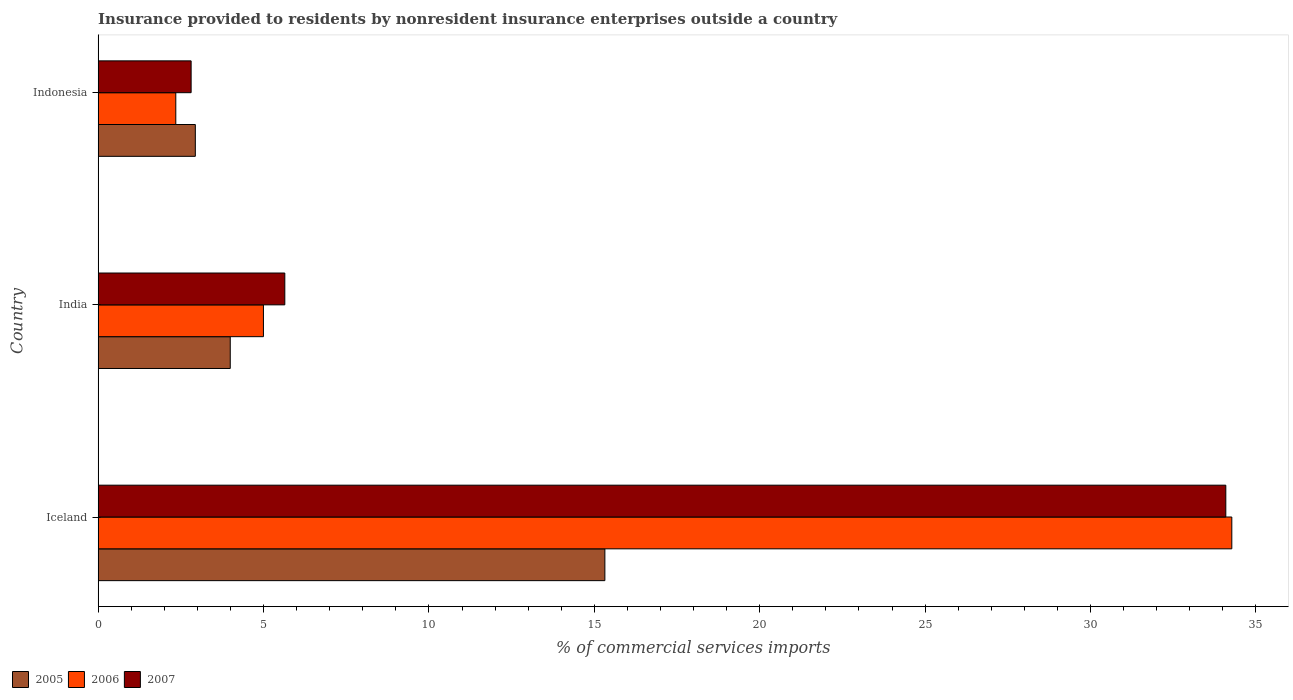How many different coloured bars are there?
Offer a terse response. 3. How many groups of bars are there?
Provide a short and direct response. 3. Are the number of bars per tick equal to the number of legend labels?
Offer a very short reply. Yes. How many bars are there on the 2nd tick from the bottom?
Your answer should be compact. 3. What is the label of the 3rd group of bars from the top?
Ensure brevity in your answer.  Iceland. What is the Insurance provided to residents in 2005 in Iceland?
Ensure brevity in your answer.  15.32. Across all countries, what is the maximum Insurance provided to residents in 2005?
Your answer should be very brief. 15.32. Across all countries, what is the minimum Insurance provided to residents in 2006?
Your answer should be very brief. 2.35. In which country was the Insurance provided to residents in 2007 maximum?
Offer a very short reply. Iceland. What is the total Insurance provided to residents in 2006 in the graph?
Ensure brevity in your answer.  41.62. What is the difference between the Insurance provided to residents in 2005 in Iceland and that in India?
Offer a terse response. 11.32. What is the difference between the Insurance provided to residents in 2007 in India and the Insurance provided to residents in 2006 in Iceland?
Offer a very short reply. -28.63. What is the average Insurance provided to residents in 2005 per country?
Your answer should be very brief. 7.42. What is the difference between the Insurance provided to residents in 2005 and Insurance provided to residents in 2007 in India?
Keep it short and to the point. -1.65. In how many countries, is the Insurance provided to residents in 2007 greater than 2 %?
Give a very brief answer. 3. What is the ratio of the Insurance provided to residents in 2006 in Iceland to that in India?
Your answer should be very brief. 6.86. What is the difference between the highest and the second highest Insurance provided to residents in 2007?
Keep it short and to the point. 28.45. What is the difference between the highest and the lowest Insurance provided to residents in 2007?
Offer a very short reply. 31.28. In how many countries, is the Insurance provided to residents in 2006 greater than the average Insurance provided to residents in 2006 taken over all countries?
Give a very brief answer. 1. What does the 3rd bar from the bottom in Iceland represents?
Give a very brief answer. 2007. Are all the bars in the graph horizontal?
Make the answer very short. Yes. How many countries are there in the graph?
Your answer should be compact. 3. Are the values on the major ticks of X-axis written in scientific E-notation?
Offer a terse response. No. Does the graph contain any zero values?
Offer a terse response. No. Does the graph contain grids?
Your answer should be compact. No. How are the legend labels stacked?
Offer a terse response. Horizontal. What is the title of the graph?
Your response must be concise. Insurance provided to residents by nonresident insurance enterprises outside a country. What is the label or title of the X-axis?
Your response must be concise. % of commercial services imports. What is the label or title of the Y-axis?
Ensure brevity in your answer.  Country. What is the % of commercial services imports in 2005 in Iceland?
Your answer should be very brief. 15.32. What is the % of commercial services imports in 2006 in Iceland?
Offer a very short reply. 34.27. What is the % of commercial services imports of 2007 in Iceland?
Offer a terse response. 34.09. What is the % of commercial services imports of 2005 in India?
Your response must be concise. 3.99. What is the % of commercial services imports of 2006 in India?
Your answer should be very brief. 5. What is the % of commercial services imports of 2007 in India?
Provide a succinct answer. 5.64. What is the % of commercial services imports in 2005 in Indonesia?
Your answer should be very brief. 2.94. What is the % of commercial services imports in 2006 in Indonesia?
Your response must be concise. 2.35. What is the % of commercial services imports in 2007 in Indonesia?
Your answer should be compact. 2.81. Across all countries, what is the maximum % of commercial services imports in 2005?
Ensure brevity in your answer.  15.32. Across all countries, what is the maximum % of commercial services imports in 2006?
Provide a short and direct response. 34.27. Across all countries, what is the maximum % of commercial services imports in 2007?
Your answer should be compact. 34.09. Across all countries, what is the minimum % of commercial services imports in 2005?
Ensure brevity in your answer.  2.94. Across all countries, what is the minimum % of commercial services imports of 2006?
Make the answer very short. 2.35. Across all countries, what is the minimum % of commercial services imports of 2007?
Provide a short and direct response. 2.81. What is the total % of commercial services imports of 2005 in the graph?
Provide a short and direct response. 22.25. What is the total % of commercial services imports of 2006 in the graph?
Ensure brevity in your answer.  41.62. What is the total % of commercial services imports in 2007 in the graph?
Your answer should be compact. 42.54. What is the difference between the % of commercial services imports of 2005 in Iceland and that in India?
Give a very brief answer. 11.32. What is the difference between the % of commercial services imports of 2006 in Iceland and that in India?
Offer a very short reply. 29.27. What is the difference between the % of commercial services imports of 2007 in Iceland and that in India?
Your answer should be compact. 28.45. What is the difference between the % of commercial services imports of 2005 in Iceland and that in Indonesia?
Your answer should be compact. 12.38. What is the difference between the % of commercial services imports of 2006 in Iceland and that in Indonesia?
Provide a succinct answer. 31.92. What is the difference between the % of commercial services imports of 2007 in Iceland and that in Indonesia?
Offer a very short reply. 31.28. What is the difference between the % of commercial services imports of 2005 in India and that in Indonesia?
Give a very brief answer. 1.06. What is the difference between the % of commercial services imports in 2006 in India and that in Indonesia?
Provide a succinct answer. 2.65. What is the difference between the % of commercial services imports of 2007 in India and that in Indonesia?
Offer a very short reply. 2.83. What is the difference between the % of commercial services imports in 2005 in Iceland and the % of commercial services imports in 2006 in India?
Your answer should be compact. 10.32. What is the difference between the % of commercial services imports in 2005 in Iceland and the % of commercial services imports in 2007 in India?
Provide a short and direct response. 9.68. What is the difference between the % of commercial services imports of 2006 in Iceland and the % of commercial services imports of 2007 in India?
Your answer should be very brief. 28.63. What is the difference between the % of commercial services imports of 2005 in Iceland and the % of commercial services imports of 2006 in Indonesia?
Ensure brevity in your answer.  12.97. What is the difference between the % of commercial services imports of 2005 in Iceland and the % of commercial services imports of 2007 in Indonesia?
Give a very brief answer. 12.51. What is the difference between the % of commercial services imports of 2006 in Iceland and the % of commercial services imports of 2007 in Indonesia?
Provide a short and direct response. 31.46. What is the difference between the % of commercial services imports in 2005 in India and the % of commercial services imports in 2006 in Indonesia?
Make the answer very short. 1.65. What is the difference between the % of commercial services imports in 2005 in India and the % of commercial services imports in 2007 in Indonesia?
Provide a short and direct response. 1.18. What is the difference between the % of commercial services imports in 2006 in India and the % of commercial services imports in 2007 in Indonesia?
Keep it short and to the point. 2.19. What is the average % of commercial services imports of 2005 per country?
Offer a terse response. 7.42. What is the average % of commercial services imports of 2006 per country?
Make the answer very short. 13.87. What is the average % of commercial services imports in 2007 per country?
Make the answer very short. 14.18. What is the difference between the % of commercial services imports of 2005 and % of commercial services imports of 2006 in Iceland?
Offer a very short reply. -18.95. What is the difference between the % of commercial services imports in 2005 and % of commercial services imports in 2007 in Iceland?
Keep it short and to the point. -18.77. What is the difference between the % of commercial services imports in 2006 and % of commercial services imports in 2007 in Iceland?
Your response must be concise. 0.18. What is the difference between the % of commercial services imports of 2005 and % of commercial services imports of 2006 in India?
Your response must be concise. -1. What is the difference between the % of commercial services imports in 2005 and % of commercial services imports in 2007 in India?
Provide a succinct answer. -1.65. What is the difference between the % of commercial services imports in 2006 and % of commercial services imports in 2007 in India?
Your response must be concise. -0.65. What is the difference between the % of commercial services imports in 2005 and % of commercial services imports in 2006 in Indonesia?
Provide a succinct answer. 0.59. What is the difference between the % of commercial services imports in 2005 and % of commercial services imports in 2007 in Indonesia?
Your answer should be very brief. 0.13. What is the difference between the % of commercial services imports of 2006 and % of commercial services imports of 2007 in Indonesia?
Provide a short and direct response. -0.46. What is the ratio of the % of commercial services imports in 2005 in Iceland to that in India?
Keep it short and to the point. 3.84. What is the ratio of the % of commercial services imports of 2006 in Iceland to that in India?
Your answer should be very brief. 6.86. What is the ratio of the % of commercial services imports of 2007 in Iceland to that in India?
Your response must be concise. 6.04. What is the ratio of the % of commercial services imports of 2005 in Iceland to that in Indonesia?
Give a very brief answer. 5.21. What is the ratio of the % of commercial services imports of 2006 in Iceland to that in Indonesia?
Ensure brevity in your answer.  14.6. What is the ratio of the % of commercial services imports in 2007 in Iceland to that in Indonesia?
Make the answer very short. 12.13. What is the ratio of the % of commercial services imports of 2005 in India to that in Indonesia?
Offer a terse response. 1.36. What is the ratio of the % of commercial services imports in 2006 in India to that in Indonesia?
Ensure brevity in your answer.  2.13. What is the ratio of the % of commercial services imports of 2007 in India to that in Indonesia?
Your answer should be very brief. 2.01. What is the difference between the highest and the second highest % of commercial services imports in 2005?
Ensure brevity in your answer.  11.32. What is the difference between the highest and the second highest % of commercial services imports of 2006?
Offer a terse response. 29.27. What is the difference between the highest and the second highest % of commercial services imports of 2007?
Your answer should be compact. 28.45. What is the difference between the highest and the lowest % of commercial services imports in 2005?
Your answer should be very brief. 12.38. What is the difference between the highest and the lowest % of commercial services imports in 2006?
Your answer should be compact. 31.92. What is the difference between the highest and the lowest % of commercial services imports of 2007?
Give a very brief answer. 31.28. 